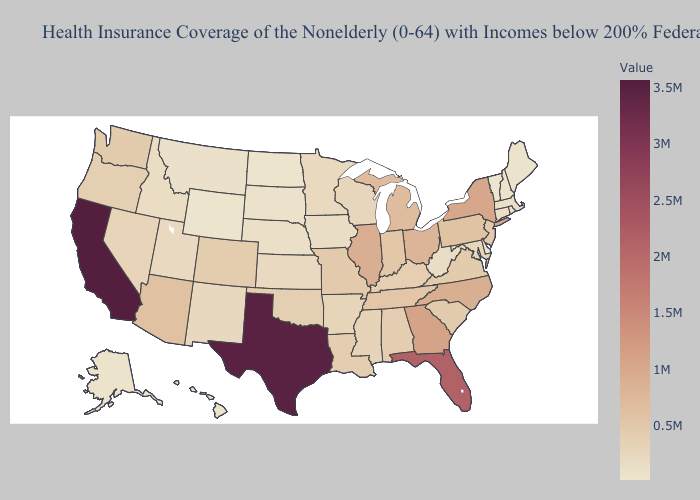Does Hawaii have the highest value in the USA?
Write a very short answer. No. Among the states that border Nevada , which have the highest value?
Keep it brief. California. Among the states that border Nebraska , does Missouri have the highest value?
Short answer required. Yes. Among the states that border Alabama , which have the lowest value?
Short answer required. Mississippi. Is the legend a continuous bar?
Write a very short answer. Yes. Does the map have missing data?
Write a very short answer. No. Does Hawaii have the highest value in the USA?
Concise answer only. No. Among the states that border North Carolina , does Georgia have the highest value?
Quick response, please. Yes. Is the legend a continuous bar?
Quick response, please. Yes. Among the states that border Massachusetts , which have the highest value?
Keep it brief. New York. 